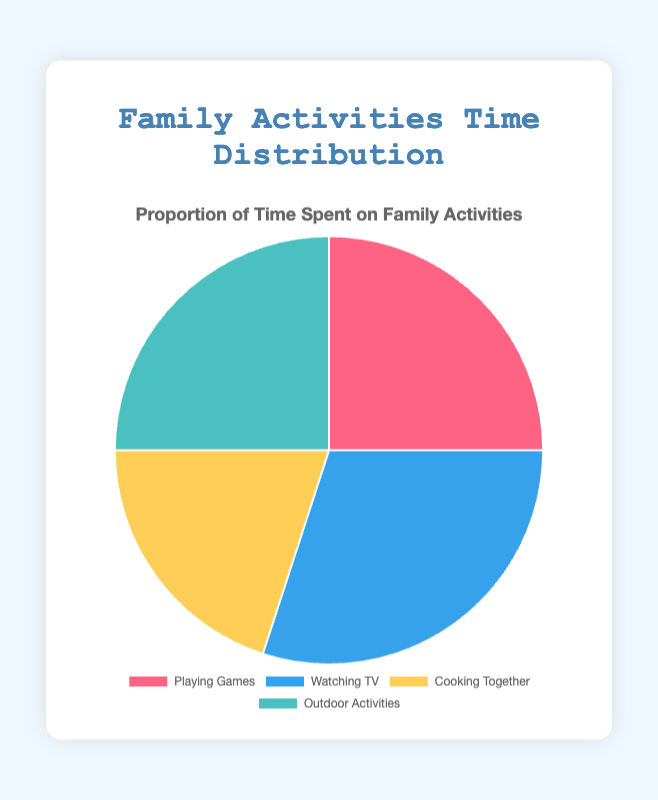Which activity do we spend the most time on? The segment labeled "Watching TV" occupies 30% of the pie chart, which is the largest proportion.
Answer: Watching TV How much more time do we spend watching TV compared to cooking together? The proportion for watching TV is 30%, and cooking together is 20%. The difference is 30% - 20% = 10%.
Answer: 10% Are playing games and outdoor activities equal in terms of time spent? Both "Playing Games" and "Outdoor Activities" segments occupy 25% of the pie chart each, indicating they are equal in time spent.
Answer: Yes What is the total proportion of time spent on playing games and outdoor activities combined? Adding the proportions of playing games (25%) and outdoor activities (25%), we get 25% + 25% = 50%.
Answer: 50% What color represents the activity with the smallest proportion of time spent? The activity with the smallest proportion is "Cooking Together" at 20%, represented by the color yellow.
Answer: Yellow If the total time spent on family activities is 10 hours in a week, how much time is spent on cooking together? The proportion for cooking together is 20%. Calculating 20% of 10 hours gives 0.20 * 10 = 2 hours.
Answer: 2 hours Which activities together make up half of the pie chart? Playing games (25%) and outdoor activities (25%) together make up 25% + 25% = 50% of the pie chart.
Answer: Playing Games and Outdoor Activities Rank the activities from the least to the most time spent. Cooking Together (20%) < Playing Games (25%) = Outdoor Activities (25%) < Watching TV (30%).
Answer: Cooking Together, Playing Games = Outdoor Activities, Watching TV What percentage less is the time spent on cooking together compared to the combined time spent on watching TV and outdoor activities? Watching TV and outdoor activities together are 30% + 25% = 55%. Cooking together is 20%. The difference is 55% - 20% = 35%.
Answer: 35% What is the average proportion of time spent across all activities? Sum the proportions (25% + 30% + 20% + 25% = 100%). The average is 100% / 4 = 25%.
Answer: 25% 